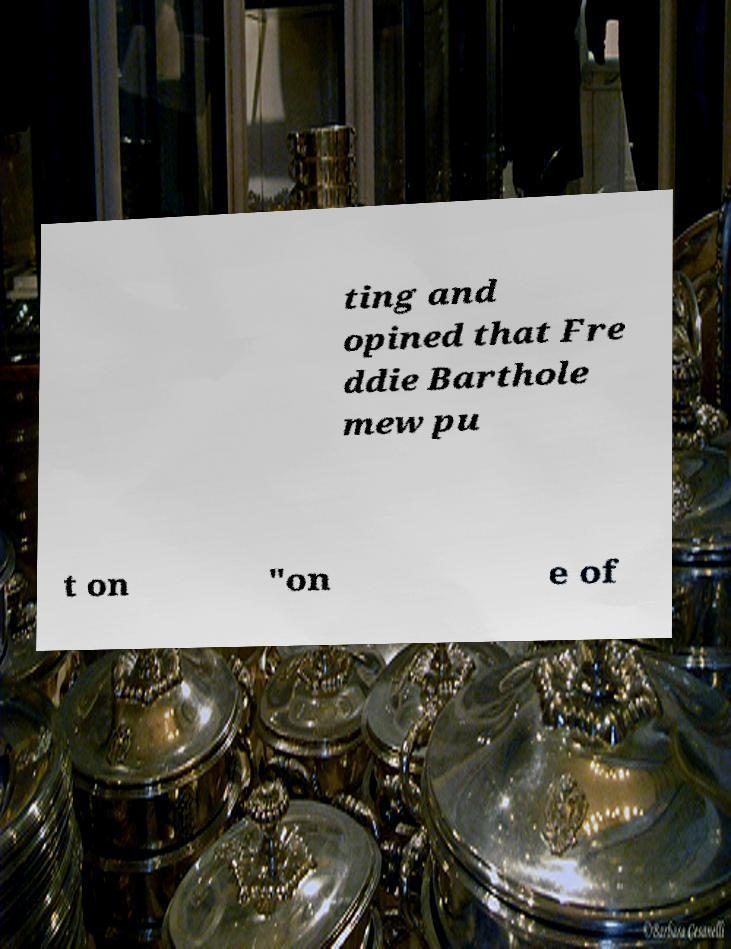For documentation purposes, I need the text within this image transcribed. Could you provide that? ting and opined that Fre ddie Barthole mew pu t on "on e of 